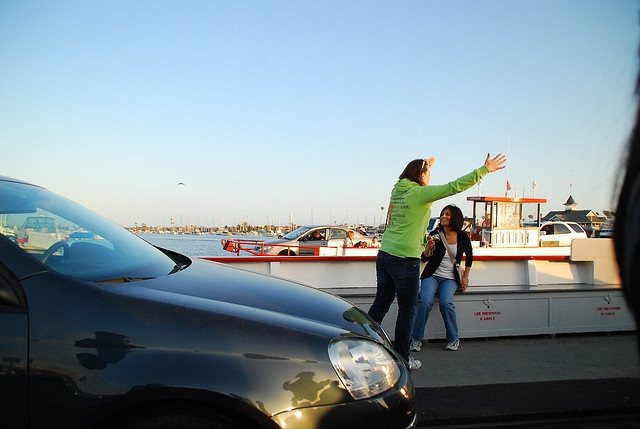Describe the objects in this image and their specific colors. I can see car in lightblue, black, gray, and blue tones, boat in lightblue, black, gray, darkgray, and ivory tones, people in lightblue, black, green, and olive tones, people in lightblue, black, blue, gray, and navy tones, and people in lightblue, black, gray, maroon, and brown tones in this image. 